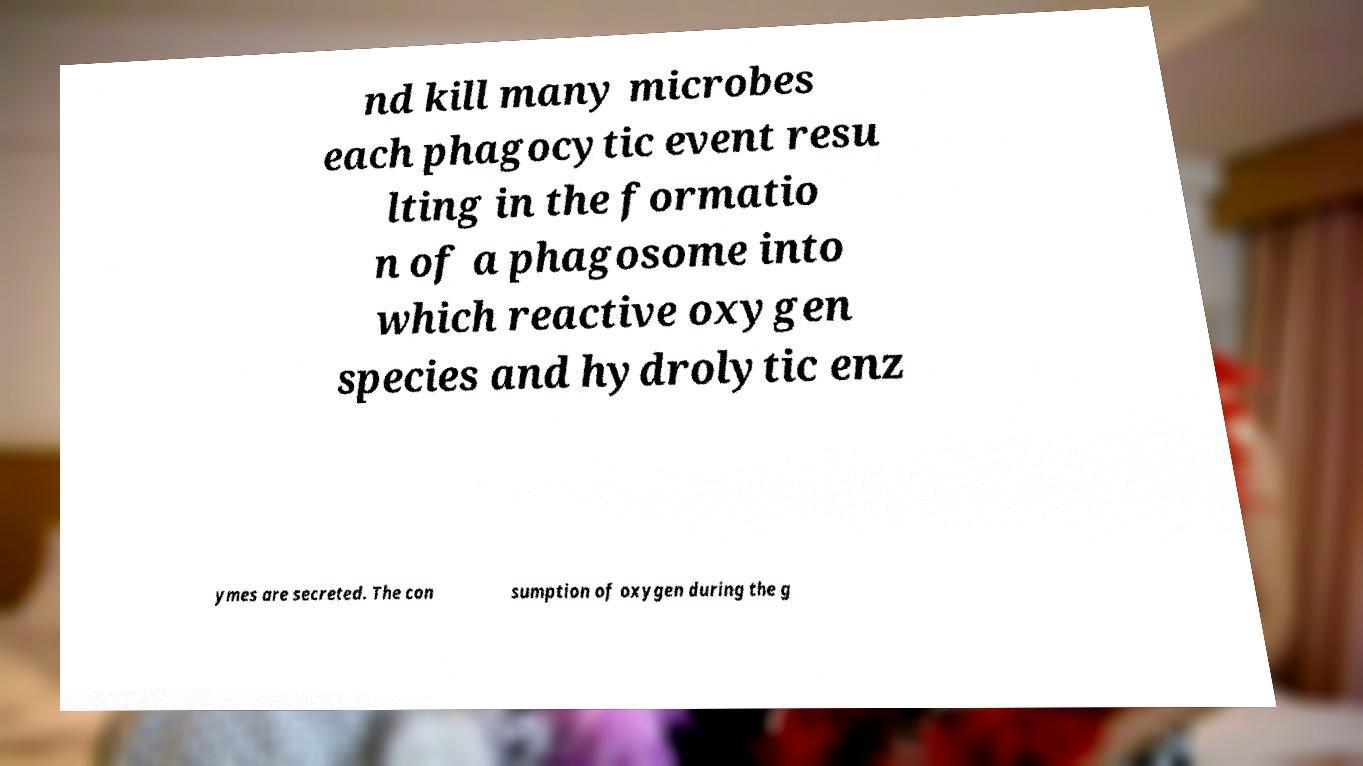I need the written content from this picture converted into text. Can you do that? nd kill many microbes each phagocytic event resu lting in the formatio n of a phagosome into which reactive oxygen species and hydrolytic enz ymes are secreted. The con sumption of oxygen during the g 